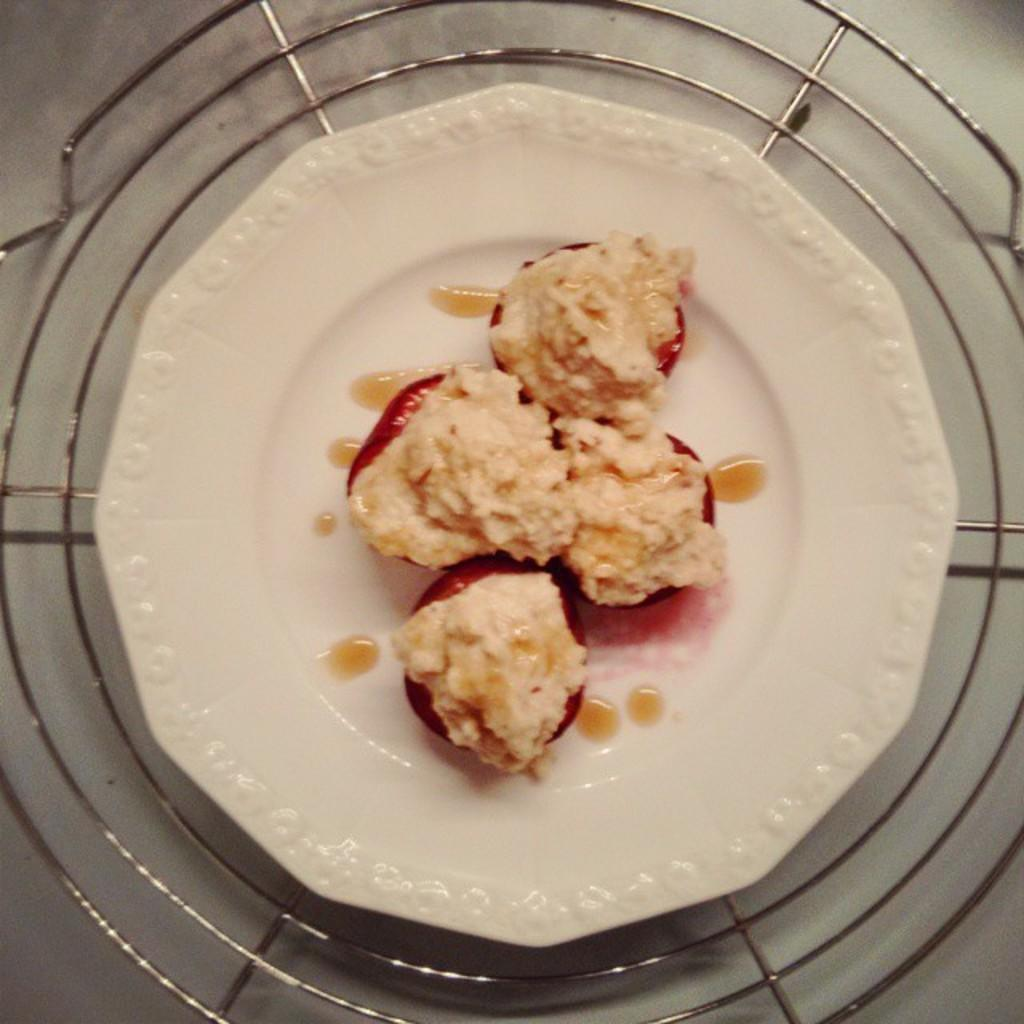What is the color of the plate that holds the food item in the image? The plate is white in color. What is the main subject of the image? The main subject of the image is a food item on a white plate. Can you describe any additional elements in the background of the image? Yes, there is a plate stand in the background of the image. What flavor of history can be tasted in the food item in the image? The image does not provide information about the flavor of the food item or any historical context related to it. 